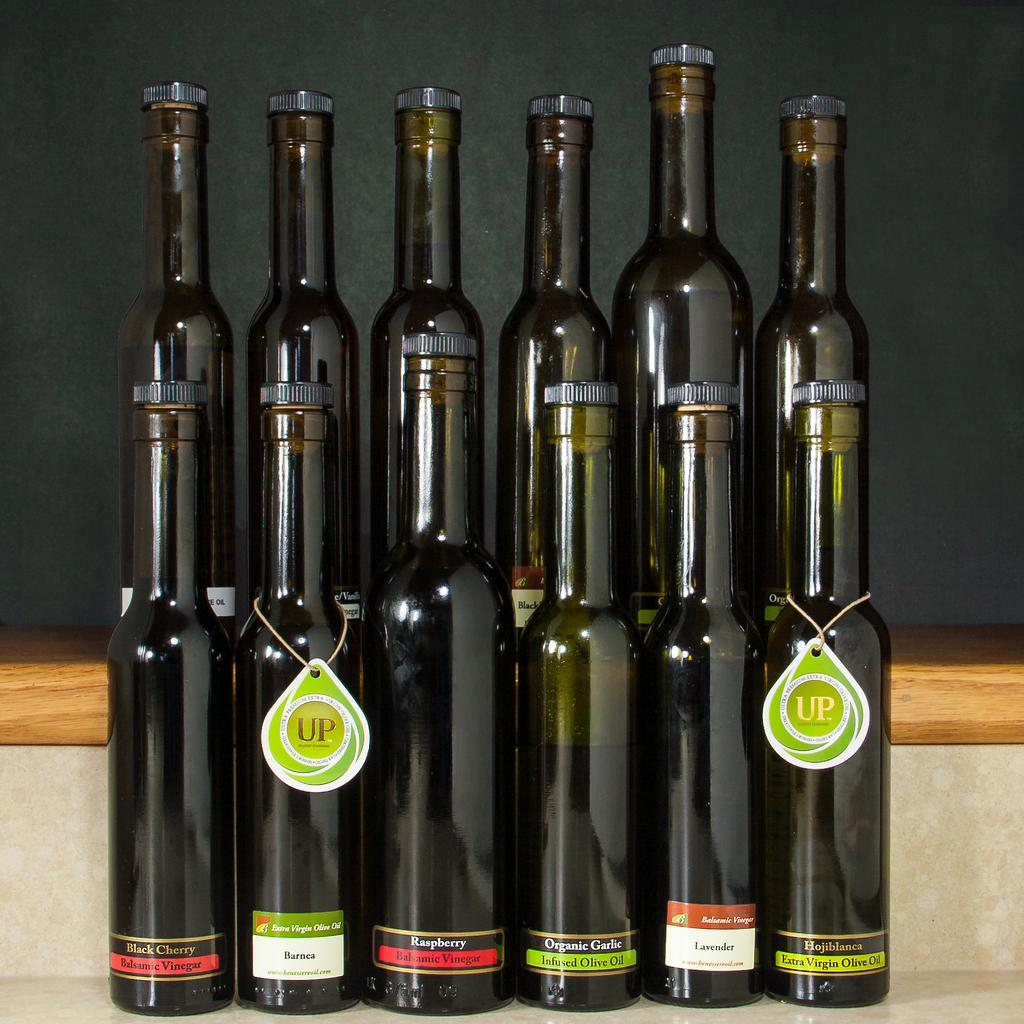What objects can be seen in the image? There are bottles in the image. Can you describe the bottles in the image? Unfortunately, the provided facts do not give any details about the bottles, so we cannot describe them further. How many tomatoes are on the fan in the image? There is no fan or tomatoes present in the image; only bottles are mentioned. 